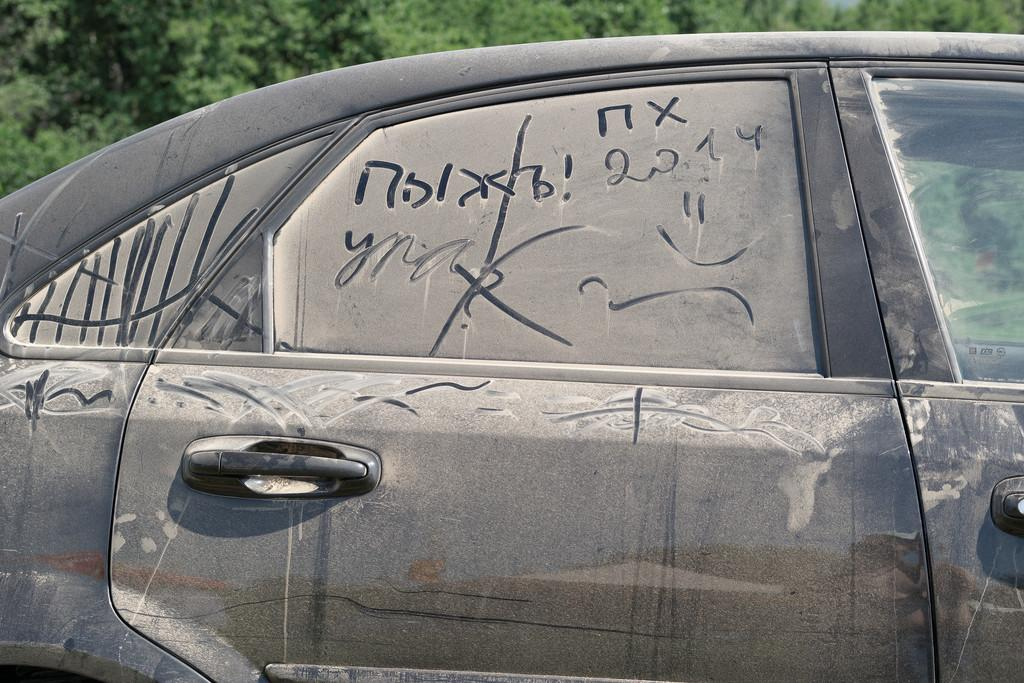What is the main subject of the image? There is a vehicle in the image. What color is the vehicle? The vehicle is black in color. What can be seen in the background of the image? There are trees in the background of the image. What type of pain can be seen on the vehicle's face in the image? There is no indication that the vehicle has a face or is experiencing pain in the image. 